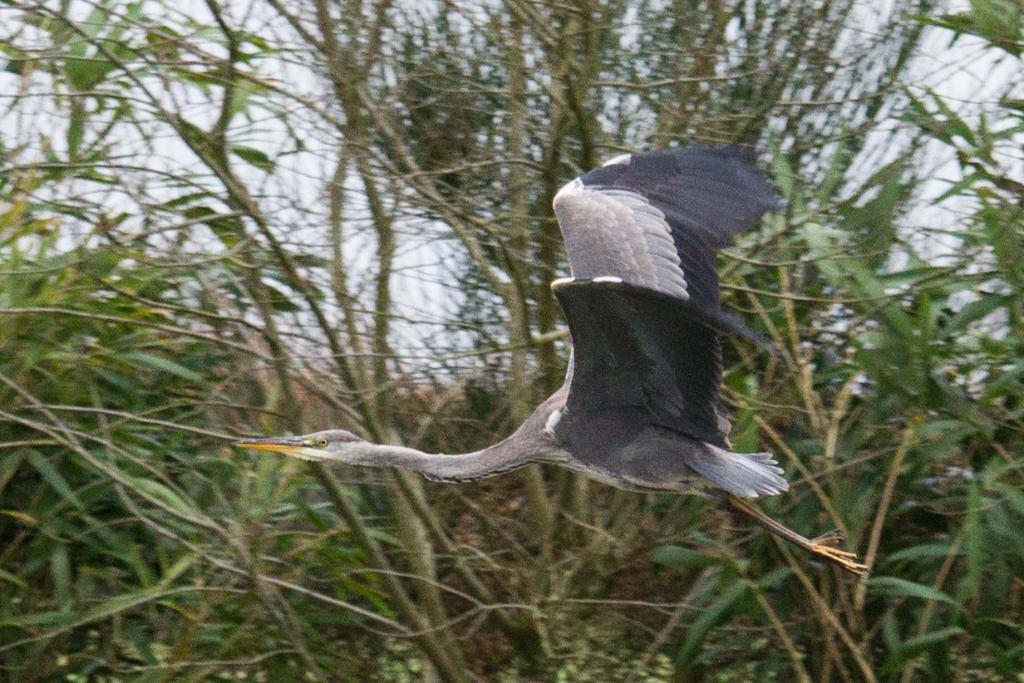What type of animal is in the image? There is a bird in the image. Can you describe the bird's coloring? The bird has a white and black color. What can be seen in the background of the image? There are trees in the background of the image. What type of prison can be seen in the image? There is no prison present in the image; it features a bird and trees in the background. How does the bird's brain function in the image? The image does not provide information about the bird's brain function, as it focuses on the bird's appearance and the background. 